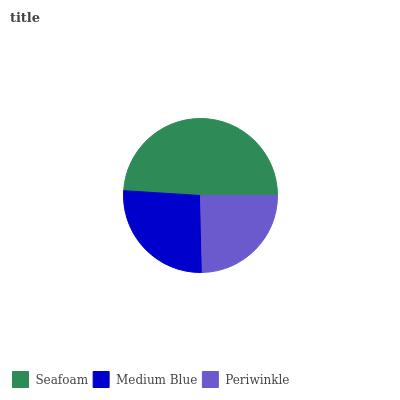Is Periwinkle the minimum?
Answer yes or no. Yes. Is Seafoam the maximum?
Answer yes or no. Yes. Is Medium Blue the minimum?
Answer yes or no. No. Is Medium Blue the maximum?
Answer yes or no. No. Is Seafoam greater than Medium Blue?
Answer yes or no. Yes. Is Medium Blue less than Seafoam?
Answer yes or no. Yes. Is Medium Blue greater than Seafoam?
Answer yes or no. No. Is Seafoam less than Medium Blue?
Answer yes or no. No. Is Medium Blue the high median?
Answer yes or no. Yes. Is Medium Blue the low median?
Answer yes or no. Yes. Is Seafoam the high median?
Answer yes or no. No. Is Periwinkle the low median?
Answer yes or no. No. 